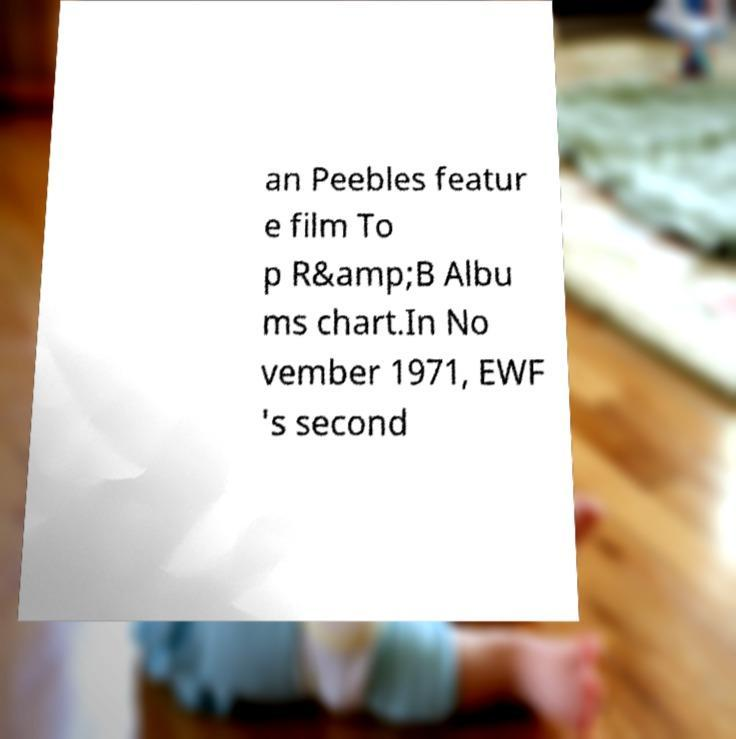What messages or text are displayed in this image? I need them in a readable, typed format. an Peebles featur e film To p R&amp;B Albu ms chart.In No vember 1971, EWF 's second 